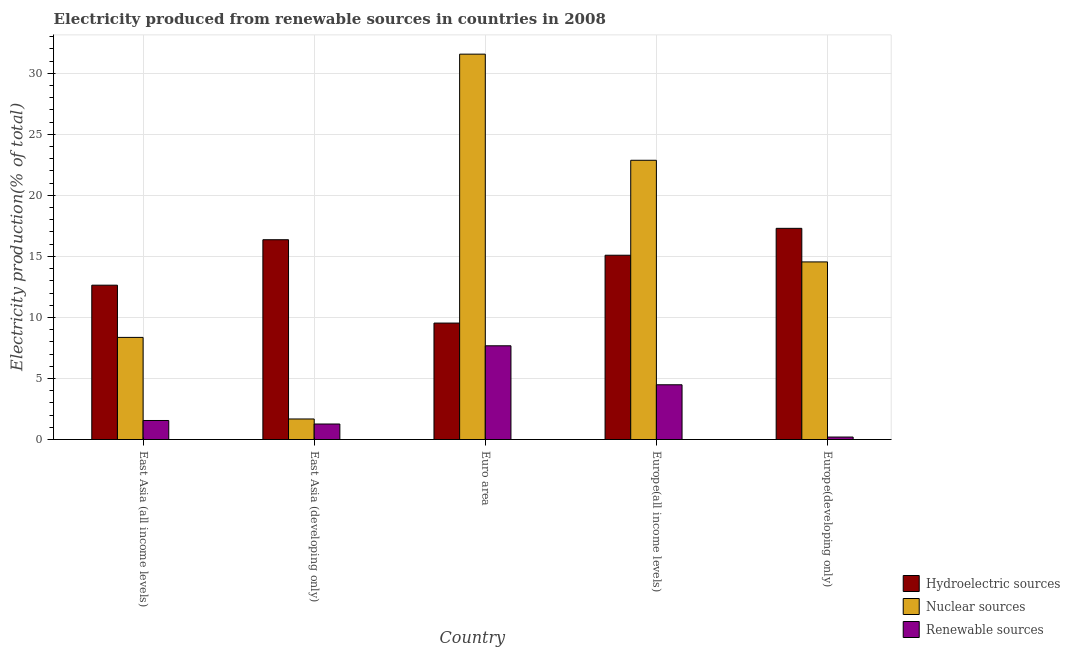How many groups of bars are there?
Offer a very short reply. 5. Are the number of bars per tick equal to the number of legend labels?
Your answer should be compact. Yes. What is the label of the 2nd group of bars from the left?
Offer a very short reply. East Asia (developing only). What is the percentage of electricity produced by nuclear sources in Europe(developing only)?
Make the answer very short. 14.55. Across all countries, what is the maximum percentage of electricity produced by hydroelectric sources?
Ensure brevity in your answer.  17.3. Across all countries, what is the minimum percentage of electricity produced by nuclear sources?
Ensure brevity in your answer.  1.68. In which country was the percentage of electricity produced by hydroelectric sources maximum?
Offer a terse response. Europe(developing only). In which country was the percentage of electricity produced by hydroelectric sources minimum?
Ensure brevity in your answer.  Euro area. What is the total percentage of electricity produced by hydroelectric sources in the graph?
Your answer should be compact. 70.95. What is the difference between the percentage of electricity produced by hydroelectric sources in East Asia (developing only) and that in Europe(all income levels)?
Your response must be concise. 1.27. What is the difference between the percentage of electricity produced by nuclear sources in Euro area and the percentage of electricity produced by renewable sources in East Asia (all income levels)?
Keep it short and to the point. 30.01. What is the average percentage of electricity produced by hydroelectric sources per country?
Make the answer very short. 14.19. What is the difference between the percentage of electricity produced by renewable sources and percentage of electricity produced by nuclear sources in Europe(developing only)?
Offer a terse response. -14.35. In how many countries, is the percentage of electricity produced by renewable sources greater than 16 %?
Your response must be concise. 0. What is the ratio of the percentage of electricity produced by renewable sources in Euro area to that in Europe(developing only)?
Provide a succinct answer. 37.86. Is the percentage of electricity produced by hydroelectric sources in East Asia (all income levels) less than that in Europe(all income levels)?
Provide a short and direct response. Yes. Is the difference between the percentage of electricity produced by nuclear sources in Euro area and Europe(developing only) greater than the difference between the percentage of electricity produced by hydroelectric sources in Euro area and Europe(developing only)?
Your response must be concise. Yes. What is the difference between the highest and the second highest percentage of electricity produced by nuclear sources?
Make the answer very short. 8.69. What is the difference between the highest and the lowest percentage of electricity produced by renewable sources?
Provide a short and direct response. 7.48. Is the sum of the percentage of electricity produced by renewable sources in Euro area and Europe(all income levels) greater than the maximum percentage of electricity produced by nuclear sources across all countries?
Make the answer very short. No. What does the 2nd bar from the left in East Asia (developing only) represents?
Your answer should be compact. Nuclear sources. What does the 2nd bar from the right in Euro area represents?
Provide a short and direct response. Nuclear sources. Is it the case that in every country, the sum of the percentage of electricity produced by hydroelectric sources and percentage of electricity produced by nuclear sources is greater than the percentage of electricity produced by renewable sources?
Ensure brevity in your answer.  Yes. How many bars are there?
Give a very brief answer. 15. Are all the bars in the graph horizontal?
Ensure brevity in your answer.  No. What is the difference between two consecutive major ticks on the Y-axis?
Offer a terse response. 5. Does the graph contain grids?
Provide a short and direct response. Yes. Where does the legend appear in the graph?
Provide a short and direct response. Bottom right. How are the legend labels stacked?
Provide a succinct answer. Vertical. What is the title of the graph?
Provide a short and direct response. Electricity produced from renewable sources in countries in 2008. Does "Agricultural Nitrous Oxide" appear as one of the legend labels in the graph?
Keep it short and to the point. No. What is the label or title of the Y-axis?
Ensure brevity in your answer.  Electricity production(% of total). What is the Electricity production(% of total) in Hydroelectric sources in East Asia (all income levels)?
Ensure brevity in your answer.  12.64. What is the Electricity production(% of total) of Nuclear sources in East Asia (all income levels)?
Offer a terse response. 8.37. What is the Electricity production(% of total) in Renewable sources in East Asia (all income levels)?
Your answer should be compact. 1.56. What is the Electricity production(% of total) of Hydroelectric sources in East Asia (developing only)?
Your response must be concise. 16.37. What is the Electricity production(% of total) in Nuclear sources in East Asia (developing only)?
Your answer should be compact. 1.68. What is the Electricity production(% of total) in Renewable sources in East Asia (developing only)?
Provide a succinct answer. 1.27. What is the Electricity production(% of total) of Hydroelectric sources in Euro area?
Give a very brief answer. 9.54. What is the Electricity production(% of total) of Nuclear sources in Euro area?
Your answer should be compact. 31.57. What is the Electricity production(% of total) in Renewable sources in Euro area?
Your answer should be very brief. 7.68. What is the Electricity production(% of total) in Hydroelectric sources in Europe(all income levels)?
Your answer should be very brief. 15.1. What is the Electricity production(% of total) in Nuclear sources in Europe(all income levels)?
Provide a succinct answer. 22.88. What is the Electricity production(% of total) in Renewable sources in Europe(all income levels)?
Offer a very short reply. 4.48. What is the Electricity production(% of total) of Hydroelectric sources in Europe(developing only)?
Ensure brevity in your answer.  17.3. What is the Electricity production(% of total) of Nuclear sources in Europe(developing only)?
Offer a very short reply. 14.55. What is the Electricity production(% of total) of Renewable sources in Europe(developing only)?
Your answer should be very brief. 0.2. Across all countries, what is the maximum Electricity production(% of total) in Hydroelectric sources?
Your answer should be very brief. 17.3. Across all countries, what is the maximum Electricity production(% of total) in Nuclear sources?
Offer a very short reply. 31.57. Across all countries, what is the maximum Electricity production(% of total) of Renewable sources?
Offer a terse response. 7.68. Across all countries, what is the minimum Electricity production(% of total) in Hydroelectric sources?
Provide a succinct answer. 9.54. Across all countries, what is the minimum Electricity production(% of total) of Nuclear sources?
Offer a very short reply. 1.68. Across all countries, what is the minimum Electricity production(% of total) in Renewable sources?
Your response must be concise. 0.2. What is the total Electricity production(% of total) in Hydroelectric sources in the graph?
Make the answer very short. 70.95. What is the total Electricity production(% of total) in Nuclear sources in the graph?
Offer a terse response. 79.04. What is the total Electricity production(% of total) in Renewable sources in the graph?
Offer a very short reply. 15.19. What is the difference between the Electricity production(% of total) of Hydroelectric sources in East Asia (all income levels) and that in East Asia (developing only)?
Provide a short and direct response. -3.72. What is the difference between the Electricity production(% of total) in Nuclear sources in East Asia (all income levels) and that in East Asia (developing only)?
Your response must be concise. 6.68. What is the difference between the Electricity production(% of total) in Renewable sources in East Asia (all income levels) and that in East Asia (developing only)?
Your answer should be very brief. 0.29. What is the difference between the Electricity production(% of total) of Hydroelectric sources in East Asia (all income levels) and that in Euro area?
Provide a short and direct response. 3.1. What is the difference between the Electricity production(% of total) in Nuclear sources in East Asia (all income levels) and that in Euro area?
Your answer should be very brief. -23.2. What is the difference between the Electricity production(% of total) in Renewable sources in East Asia (all income levels) and that in Euro area?
Offer a terse response. -6.12. What is the difference between the Electricity production(% of total) in Hydroelectric sources in East Asia (all income levels) and that in Europe(all income levels)?
Your answer should be compact. -2.45. What is the difference between the Electricity production(% of total) in Nuclear sources in East Asia (all income levels) and that in Europe(all income levels)?
Keep it short and to the point. -14.51. What is the difference between the Electricity production(% of total) of Renewable sources in East Asia (all income levels) and that in Europe(all income levels)?
Keep it short and to the point. -2.93. What is the difference between the Electricity production(% of total) in Hydroelectric sources in East Asia (all income levels) and that in Europe(developing only)?
Ensure brevity in your answer.  -4.66. What is the difference between the Electricity production(% of total) in Nuclear sources in East Asia (all income levels) and that in Europe(developing only)?
Offer a terse response. -6.18. What is the difference between the Electricity production(% of total) in Renewable sources in East Asia (all income levels) and that in Europe(developing only)?
Make the answer very short. 1.36. What is the difference between the Electricity production(% of total) of Hydroelectric sources in East Asia (developing only) and that in Euro area?
Ensure brevity in your answer.  6.83. What is the difference between the Electricity production(% of total) of Nuclear sources in East Asia (developing only) and that in Euro area?
Provide a short and direct response. -29.89. What is the difference between the Electricity production(% of total) of Renewable sources in East Asia (developing only) and that in Euro area?
Ensure brevity in your answer.  -6.41. What is the difference between the Electricity production(% of total) of Hydroelectric sources in East Asia (developing only) and that in Europe(all income levels)?
Your answer should be very brief. 1.27. What is the difference between the Electricity production(% of total) of Nuclear sources in East Asia (developing only) and that in Europe(all income levels)?
Your answer should be compact. -21.19. What is the difference between the Electricity production(% of total) of Renewable sources in East Asia (developing only) and that in Europe(all income levels)?
Offer a terse response. -3.21. What is the difference between the Electricity production(% of total) in Hydroelectric sources in East Asia (developing only) and that in Europe(developing only)?
Provide a succinct answer. -0.93. What is the difference between the Electricity production(% of total) in Nuclear sources in East Asia (developing only) and that in Europe(developing only)?
Make the answer very short. -12.87. What is the difference between the Electricity production(% of total) of Renewable sources in East Asia (developing only) and that in Europe(developing only)?
Provide a succinct answer. 1.07. What is the difference between the Electricity production(% of total) in Hydroelectric sources in Euro area and that in Europe(all income levels)?
Make the answer very short. -5.56. What is the difference between the Electricity production(% of total) of Nuclear sources in Euro area and that in Europe(all income levels)?
Offer a terse response. 8.69. What is the difference between the Electricity production(% of total) in Renewable sources in Euro area and that in Europe(all income levels)?
Offer a terse response. 3.19. What is the difference between the Electricity production(% of total) of Hydroelectric sources in Euro area and that in Europe(developing only)?
Your answer should be very brief. -7.76. What is the difference between the Electricity production(% of total) in Nuclear sources in Euro area and that in Europe(developing only)?
Ensure brevity in your answer.  17.02. What is the difference between the Electricity production(% of total) in Renewable sources in Euro area and that in Europe(developing only)?
Offer a very short reply. 7.48. What is the difference between the Electricity production(% of total) of Hydroelectric sources in Europe(all income levels) and that in Europe(developing only)?
Make the answer very short. -2.2. What is the difference between the Electricity production(% of total) of Nuclear sources in Europe(all income levels) and that in Europe(developing only)?
Offer a very short reply. 8.33. What is the difference between the Electricity production(% of total) in Renewable sources in Europe(all income levels) and that in Europe(developing only)?
Your response must be concise. 4.28. What is the difference between the Electricity production(% of total) in Hydroelectric sources in East Asia (all income levels) and the Electricity production(% of total) in Nuclear sources in East Asia (developing only)?
Make the answer very short. 10.96. What is the difference between the Electricity production(% of total) of Hydroelectric sources in East Asia (all income levels) and the Electricity production(% of total) of Renewable sources in East Asia (developing only)?
Keep it short and to the point. 11.37. What is the difference between the Electricity production(% of total) of Nuclear sources in East Asia (all income levels) and the Electricity production(% of total) of Renewable sources in East Asia (developing only)?
Make the answer very short. 7.09. What is the difference between the Electricity production(% of total) of Hydroelectric sources in East Asia (all income levels) and the Electricity production(% of total) of Nuclear sources in Euro area?
Your answer should be very brief. -18.93. What is the difference between the Electricity production(% of total) in Hydroelectric sources in East Asia (all income levels) and the Electricity production(% of total) in Renewable sources in Euro area?
Your answer should be compact. 4.96. What is the difference between the Electricity production(% of total) in Nuclear sources in East Asia (all income levels) and the Electricity production(% of total) in Renewable sources in Euro area?
Your answer should be compact. 0.69. What is the difference between the Electricity production(% of total) in Hydroelectric sources in East Asia (all income levels) and the Electricity production(% of total) in Nuclear sources in Europe(all income levels)?
Provide a short and direct response. -10.23. What is the difference between the Electricity production(% of total) in Hydroelectric sources in East Asia (all income levels) and the Electricity production(% of total) in Renewable sources in Europe(all income levels)?
Your response must be concise. 8.16. What is the difference between the Electricity production(% of total) in Nuclear sources in East Asia (all income levels) and the Electricity production(% of total) in Renewable sources in Europe(all income levels)?
Keep it short and to the point. 3.88. What is the difference between the Electricity production(% of total) in Hydroelectric sources in East Asia (all income levels) and the Electricity production(% of total) in Nuclear sources in Europe(developing only)?
Make the answer very short. -1.91. What is the difference between the Electricity production(% of total) in Hydroelectric sources in East Asia (all income levels) and the Electricity production(% of total) in Renewable sources in Europe(developing only)?
Ensure brevity in your answer.  12.44. What is the difference between the Electricity production(% of total) of Nuclear sources in East Asia (all income levels) and the Electricity production(% of total) of Renewable sources in Europe(developing only)?
Give a very brief answer. 8.16. What is the difference between the Electricity production(% of total) in Hydroelectric sources in East Asia (developing only) and the Electricity production(% of total) in Nuclear sources in Euro area?
Offer a very short reply. -15.2. What is the difference between the Electricity production(% of total) of Hydroelectric sources in East Asia (developing only) and the Electricity production(% of total) of Renewable sources in Euro area?
Offer a very short reply. 8.69. What is the difference between the Electricity production(% of total) in Nuclear sources in East Asia (developing only) and the Electricity production(% of total) in Renewable sources in Euro area?
Your response must be concise. -6. What is the difference between the Electricity production(% of total) of Hydroelectric sources in East Asia (developing only) and the Electricity production(% of total) of Nuclear sources in Europe(all income levels)?
Offer a very short reply. -6.51. What is the difference between the Electricity production(% of total) in Hydroelectric sources in East Asia (developing only) and the Electricity production(% of total) in Renewable sources in Europe(all income levels)?
Provide a succinct answer. 11.88. What is the difference between the Electricity production(% of total) of Nuclear sources in East Asia (developing only) and the Electricity production(% of total) of Renewable sources in Europe(all income levels)?
Provide a short and direct response. -2.8. What is the difference between the Electricity production(% of total) of Hydroelectric sources in East Asia (developing only) and the Electricity production(% of total) of Nuclear sources in Europe(developing only)?
Your answer should be compact. 1.82. What is the difference between the Electricity production(% of total) in Hydroelectric sources in East Asia (developing only) and the Electricity production(% of total) in Renewable sources in Europe(developing only)?
Provide a succinct answer. 16.16. What is the difference between the Electricity production(% of total) of Nuclear sources in East Asia (developing only) and the Electricity production(% of total) of Renewable sources in Europe(developing only)?
Offer a very short reply. 1.48. What is the difference between the Electricity production(% of total) in Hydroelectric sources in Euro area and the Electricity production(% of total) in Nuclear sources in Europe(all income levels)?
Ensure brevity in your answer.  -13.34. What is the difference between the Electricity production(% of total) of Hydroelectric sources in Euro area and the Electricity production(% of total) of Renewable sources in Europe(all income levels)?
Ensure brevity in your answer.  5.05. What is the difference between the Electricity production(% of total) of Nuclear sources in Euro area and the Electricity production(% of total) of Renewable sources in Europe(all income levels)?
Offer a terse response. 27.09. What is the difference between the Electricity production(% of total) of Hydroelectric sources in Euro area and the Electricity production(% of total) of Nuclear sources in Europe(developing only)?
Ensure brevity in your answer.  -5.01. What is the difference between the Electricity production(% of total) in Hydroelectric sources in Euro area and the Electricity production(% of total) in Renewable sources in Europe(developing only)?
Ensure brevity in your answer.  9.34. What is the difference between the Electricity production(% of total) in Nuclear sources in Euro area and the Electricity production(% of total) in Renewable sources in Europe(developing only)?
Ensure brevity in your answer.  31.37. What is the difference between the Electricity production(% of total) of Hydroelectric sources in Europe(all income levels) and the Electricity production(% of total) of Nuclear sources in Europe(developing only)?
Offer a very short reply. 0.55. What is the difference between the Electricity production(% of total) in Hydroelectric sources in Europe(all income levels) and the Electricity production(% of total) in Renewable sources in Europe(developing only)?
Your answer should be compact. 14.89. What is the difference between the Electricity production(% of total) of Nuclear sources in Europe(all income levels) and the Electricity production(% of total) of Renewable sources in Europe(developing only)?
Provide a succinct answer. 22.67. What is the average Electricity production(% of total) in Hydroelectric sources per country?
Keep it short and to the point. 14.19. What is the average Electricity production(% of total) of Nuclear sources per country?
Offer a terse response. 15.81. What is the average Electricity production(% of total) of Renewable sources per country?
Make the answer very short. 3.04. What is the difference between the Electricity production(% of total) of Hydroelectric sources and Electricity production(% of total) of Nuclear sources in East Asia (all income levels)?
Your answer should be very brief. 4.28. What is the difference between the Electricity production(% of total) in Hydroelectric sources and Electricity production(% of total) in Renewable sources in East Asia (all income levels)?
Give a very brief answer. 11.09. What is the difference between the Electricity production(% of total) in Nuclear sources and Electricity production(% of total) in Renewable sources in East Asia (all income levels)?
Your answer should be very brief. 6.81. What is the difference between the Electricity production(% of total) in Hydroelectric sources and Electricity production(% of total) in Nuclear sources in East Asia (developing only)?
Make the answer very short. 14.68. What is the difference between the Electricity production(% of total) in Hydroelectric sources and Electricity production(% of total) in Renewable sources in East Asia (developing only)?
Keep it short and to the point. 15.1. What is the difference between the Electricity production(% of total) of Nuclear sources and Electricity production(% of total) of Renewable sources in East Asia (developing only)?
Keep it short and to the point. 0.41. What is the difference between the Electricity production(% of total) of Hydroelectric sources and Electricity production(% of total) of Nuclear sources in Euro area?
Ensure brevity in your answer.  -22.03. What is the difference between the Electricity production(% of total) of Hydroelectric sources and Electricity production(% of total) of Renewable sources in Euro area?
Your answer should be compact. 1.86. What is the difference between the Electricity production(% of total) in Nuclear sources and Electricity production(% of total) in Renewable sources in Euro area?
Your response must be concise. 23.89. What is the difference between the Electricity production(% of total) in Hydroelectric sources and Electricity production(% of total) in Nuclear sources in Europe(all income levels)?
Offer a terse response. -7.78. What is the difference between the Electricity production(% of total) in Hydroelectric sources and Electricity production(% of total) in Renewable sources in Europe(all income levels)?
Your answer should be very brief. 10.61. What is the difference between the Electricity production(% of total) in Nuclear sources and Electricity production(% of total) in Renewable sources in Europe(all income levels)?
Offer a very short reply. 18.39. What is the difference between the Electricity production(% of total) in Hydroelectric sources and Electricity production(% of total) in Nuclear sources in Europe(developing only)?
Provide a succinct answer. 2.75. What is the difference between the Electricity production(% of total) in Hydroelectric sources and Electricity production(% of total) in Renewable sources in Europe(developing only)?
Make the answer very short. 17.1. What is the difference between the Electricity production(% of total) in Nuclear sources and Electricity production(% of total) in Renewable sources in Europe(developing only)?
Your answer should be very brief. 14.35. What is the ratio of the Electricity production(% of total) in Hydroelectric sources in East Asia (all income levels) to that in East Asia (developing only)?
Your answer should be compact. 0.77. What is the ratio of the Electricity production(% of total) in Nuclear sources in East Asia (all income levels) to that in East Asia (developing only)?
Your response must be concise. 4.97. What is the ratio of the Electricity production(% of total) of Renewable sources in East Asia (all income levels) to that in East Asia (developing only)?
Offer a terse response. 1.23. What is the ratio of the Electricity production(% of total) in Hydroelectric sources in East Asia (all income levels) to that in Euro area?
Keep it short and to the point. 1.33. What is the ratio of the Electricity production(% of total) of Nuclear sources in East Asia (all income levels) to that in Euro area?
Give a very brief answer. 0.27. What is the ratio of the Electricity production(% of total) in Renewable sources in East Asia (all income levels) to that in Euro area?
Your answer should be compact. 0.2. What is the ratio of the Electricity production(% of total) of Hydroelectric sources in East Asia (all income levels) to that in Europe(all income levels)?
Give a very brief answer. 0.84. What is the ratio of the Electricity production(% of total) in Nuclear sources in East Asia (all income levels) to that in Europe(all income levels)?
Offer a very short reply. 0.37. What is the ratio of the Electricity production(% of total) in Renewable sources in East Asia (all income levels) to that in Europe(all income levels)?
Keep it short and to the point. 0.35. What is the ratio of the Electricity production(% of total) in Hydroelectric sources in East Asia (all income levels) to that in Europe(developing only)?
Make the answer very short. 0.73. What is the ratio of the Electricity production(% of total) in Nuclear sources in East Asia (all income levels) to that in Europe(developing only)?
Provide a short and direct response. 0.57. What is the ratio of the Electricity production(% of total) in Renewable sources in East Asia (all income levels) to that in Europe(developing only)?
Give a very brief answer. 7.68. What is the ratio of the Electricity production(% of total) of Hydroelectric sources in East Asia (developing only) to that in Euro area?
Provide a succinct answer. 1.72. What is the ratio of the Electricity production(% of total) in Nuclear sources in East Asia (developing only) to that in Euro area?
Provide a succinct answer. 0.05. What is the ratio of the Electricity production(% of total) in Renewable sources in East Asia (developing only) to that in Euro area?
Make the answer very short. 0.17. What is the ratio of the Electricity production(% of total) of Hydroelectric sources in East Asia (developing only) to that in Europe(all income levels)?
Offer a terse response. 1.08. What is the ratio of the Electricity production(% of total) in Nuclear sources in East Asia (developing only) to that in Europe(all income levels)?
Keep it short and to the point. 0.07. What is the ratio of the Electricity production(% of total) in Renewable sources in East Asia (developing only) to that in Europe(all income levels)?
Offer a terse response. 0.28. What is the ratio of the Electricity production(% of total) in Hydroelectric sources in East Asia (developing only) to that in Europe(developing only)?
Make the answer very short. 0.95. What is the ratio of the Electricity production(% of total) of Nuclear sources in East Asia (developing only) to that in Europe(developing only)?
Keep it short and to the point. 0.12. What is the ratio of the Electricity production(% of total) in Renewable sources in East Asia (developing only) to that in Europe(developing only)?
Offer a very short reply. 6.27. What is the ratio of the Electricity production(% of total) of Hydroelectric sources in Euro area to that in Europe(all income levels)?
Your response must be concise. 0.63. What is the ratio of the Electricity production(% of total) in Nuclear sources in Euro area to that in Europe(all income levels)?
Offer a terse response. 1.38. What is the ratio of the Electricity production(% of total) in Renewable sources in Euro area to that in Europe(all income levels)?
Offer a terse response. 1.71. What is the ratio of the Electricity production(% of total) in Hydroelectric sources in Euro area to that in Europe(developing only)?
Provide a short and direct response. 0.55. What is the ratio of the Electricity production(% of total) in Nuclear sources in Euro area to that in Europe(developing only)?
Provide a short and direct response. 2.17. What is the ratio of the Electricity production(% of total) of Renewable sources in Euro area to that in Europe(developing only)?
Give a very brief answer. 37.86. What is the ratio of the Electricity production(% of total) in Hydroelectric sources in Europe(all income levels) to that in Europe(developing only)?
Offer a very short reply. 0.87. What is the ratio of the Electricity production(% of total) of Nuclear sources in Europe(all income levels) to that in Europe(developing only)?
Your answer should be very brief. 1.57. What is the ratio of the Electricity production(% of total) in Renewable sources in Europe(all income levels) to that in Europe(developing only)?
Offer a very short reply. 22.11. What is the difference between the highest and the second highest Electricity production(% of total) of Hydroelectric sources?
Provide a short and direct response. 0.93. What is the difference between the highest and the second highest Electricity production(% of total) of Nuclear sources?
Ensure brevity in your answer.  8.69. What is the difference between the highest and the second highest Electricity production(% of total) in Renewable sources?
Keep it short and to the point. 3.19. What is the difference between the highest and the lowest Electricity production(% of total) of Hydroelectric sources?
Your answer should be compact. 7.76. What is the difference between the highest and the lowest Electricity production(% of total) of Nuclear sources?
Ensure brevity in your answer.  29.89. What is the difference between the highest and the lowest Electricity production(% of total) in Renewable sources?
Your response must be concise. 7.48. 